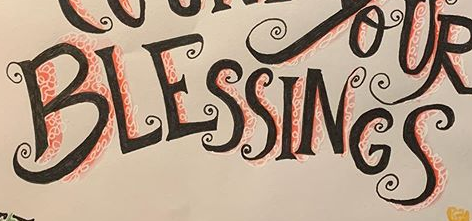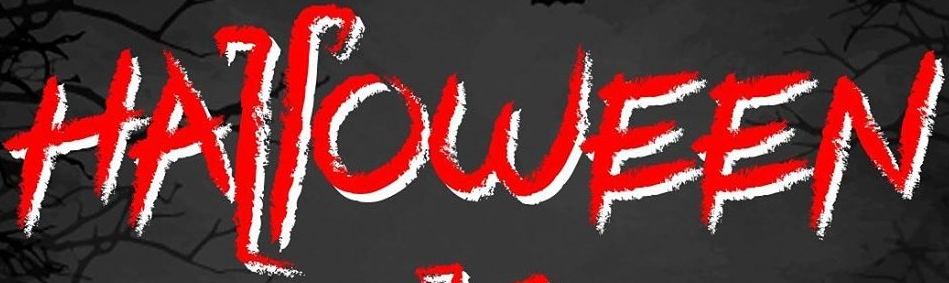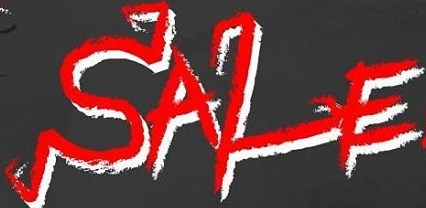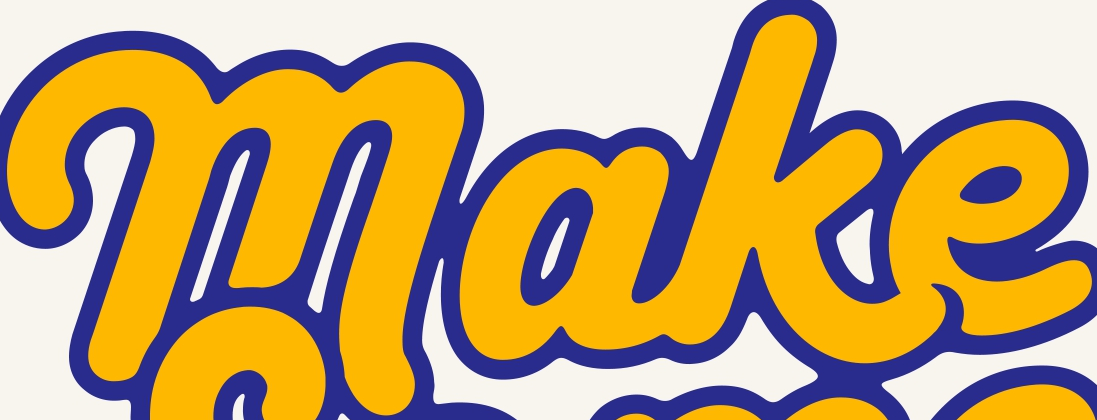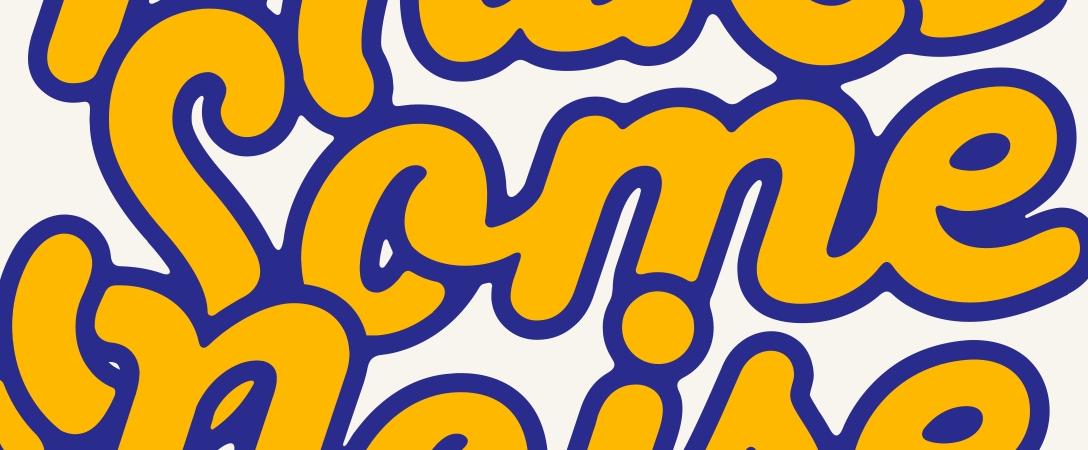What words can you see in these images in sequence, separated by a semicolon? BLESSINGS; HALLOWEEN; SALE; make; Some 